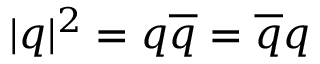<formula> <loc_0><loc_0><loc_500><loc_500>| q | ^ { 2 } = q \overline { q } = \overline { q } q</formula> 